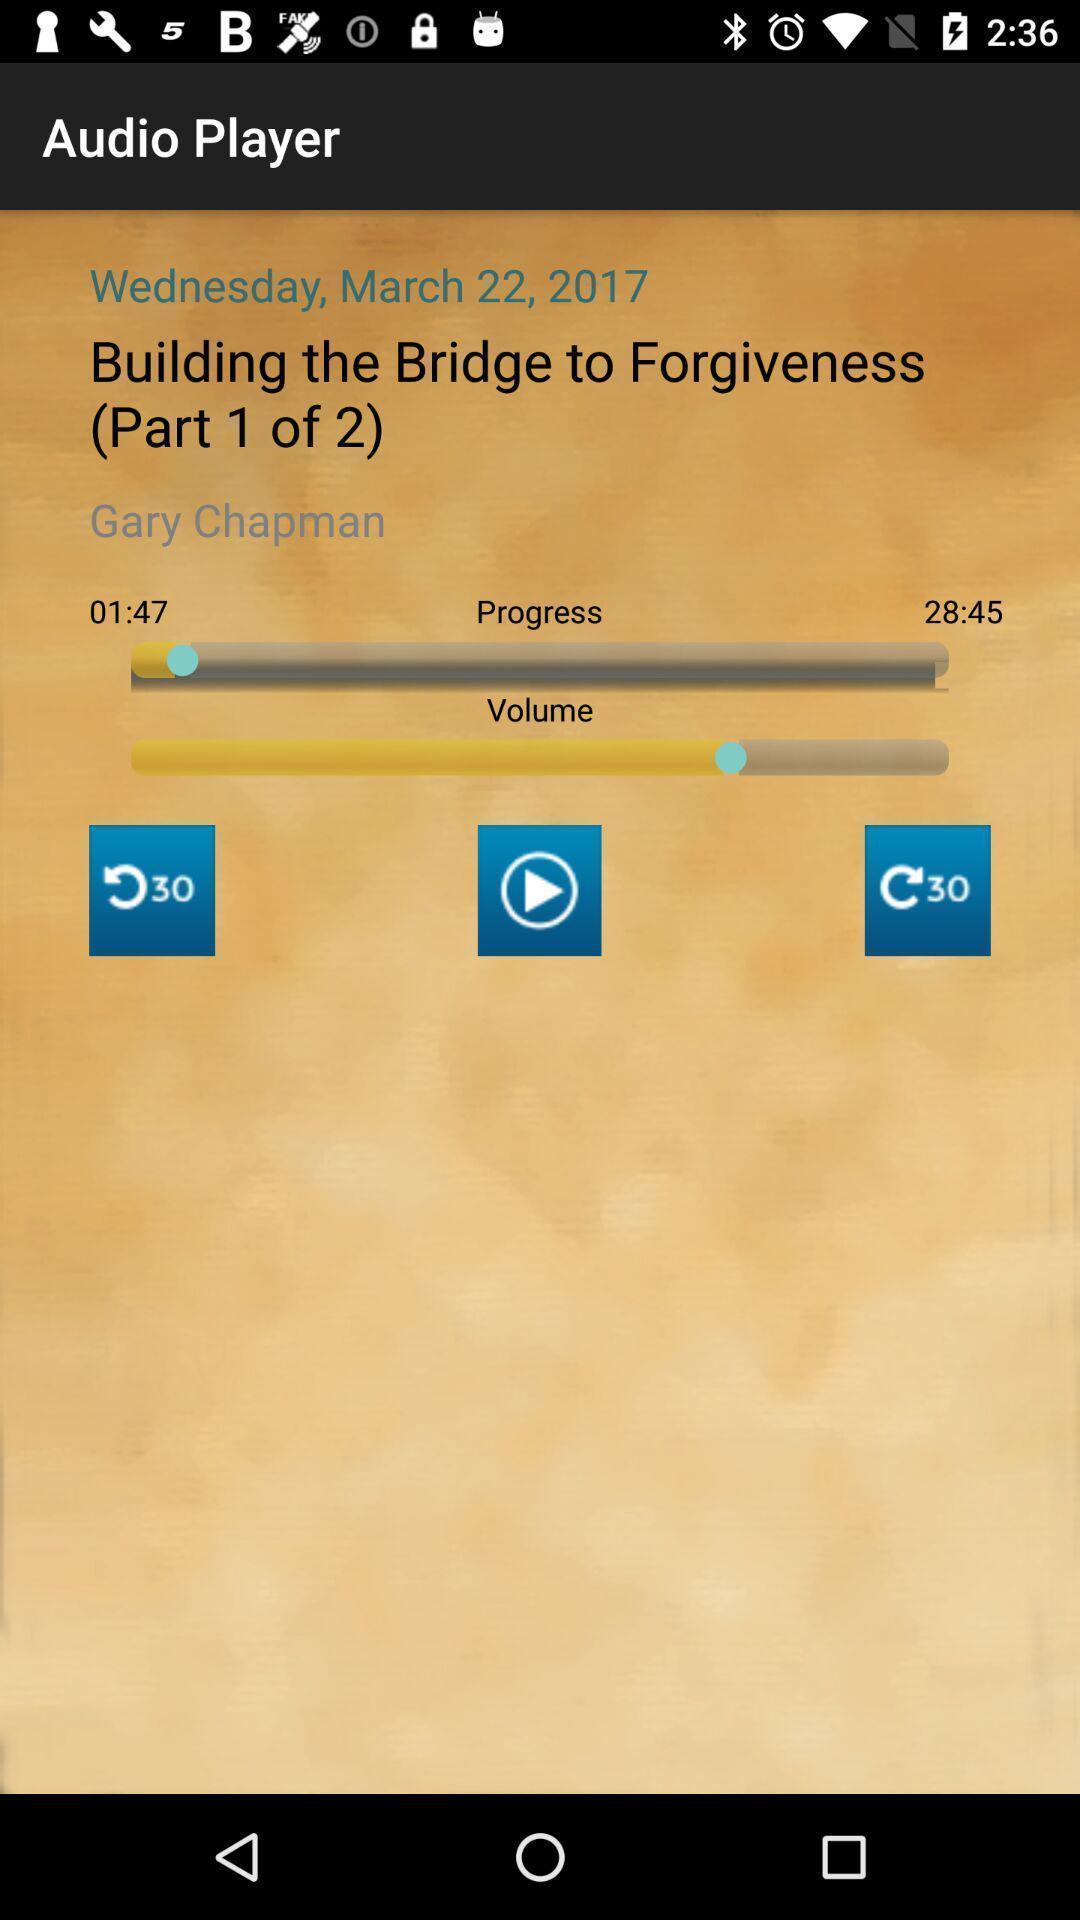Provide a description of this screenshot. Page displays audio in music app. 